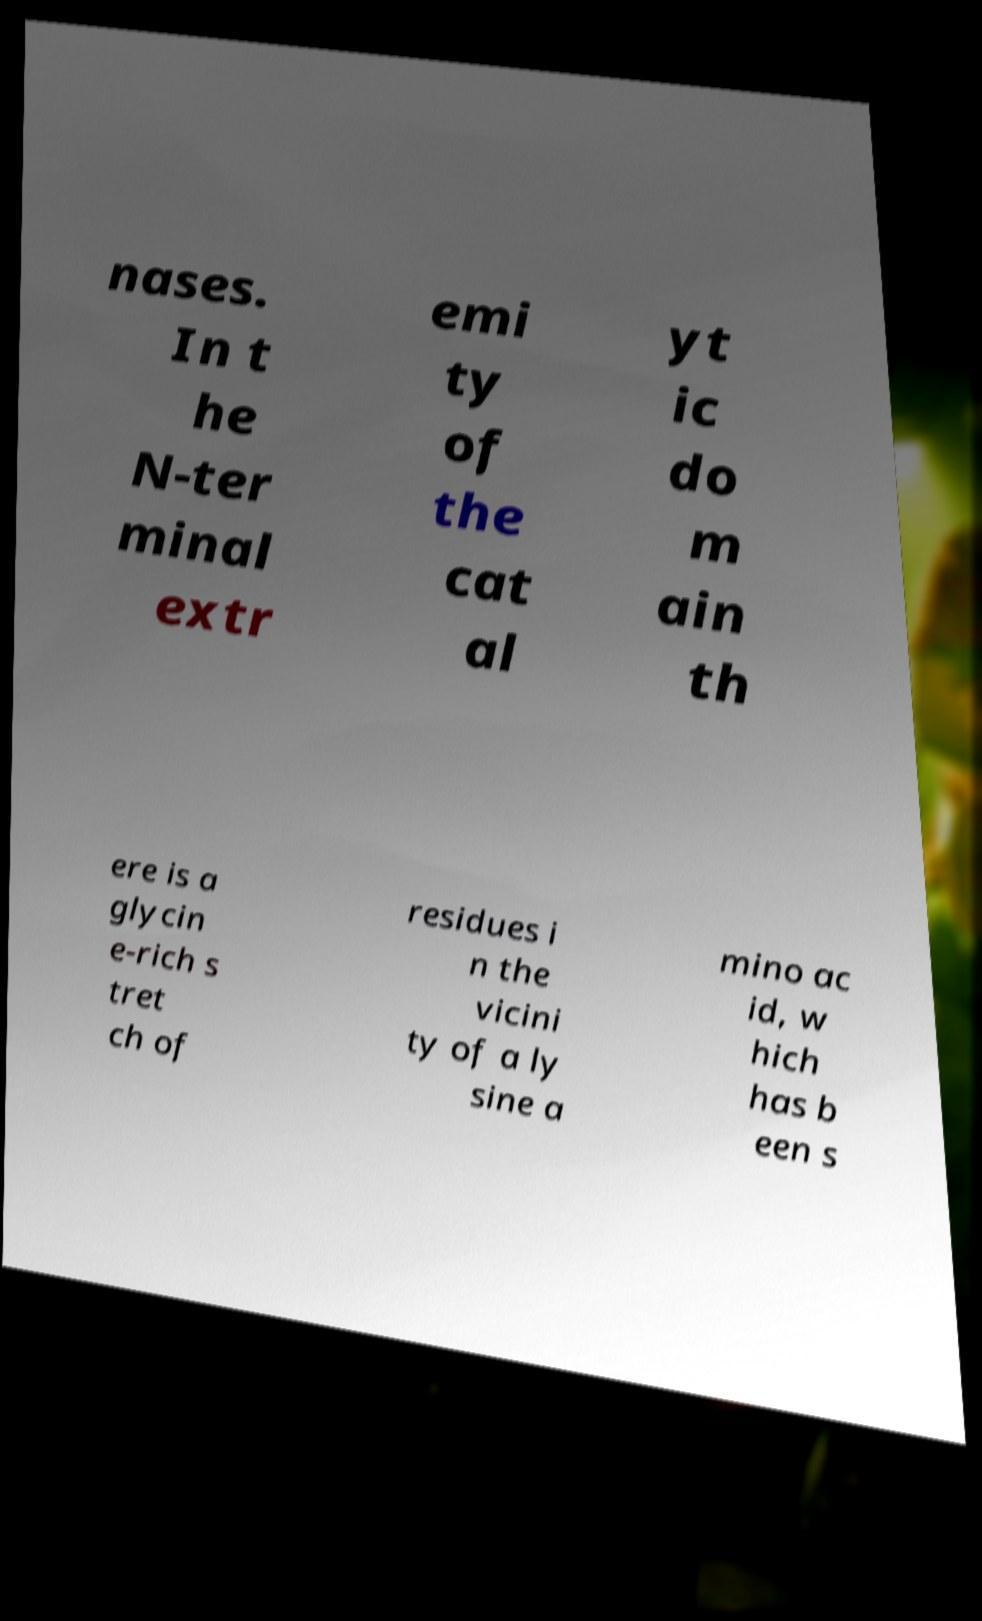Please read and relay the text visible in this image. What does it say? nases. In t he N-ter minal extr emi ty of the cat al yt ic do m ain th ere is a glycin e-rich s tret ch of residues i n the vicini ty of a ly sine a mino ac id, w hich has b een s 